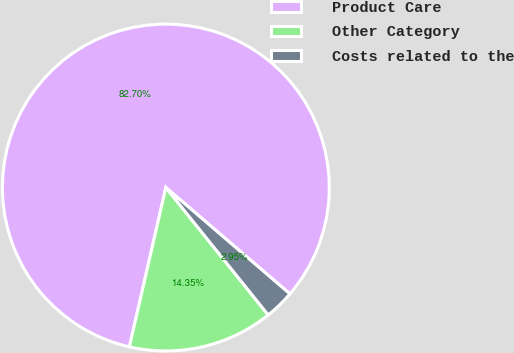Convert chart. <chart><loc_0><loc_0><loc_500><loc_500><pie_chart><fcel>Product Care<fcel>Other Category<fcel>Costs related to the<nl><fcel>82.7%<fcel>14.35%<fcel>2.95%<nl></chart> 